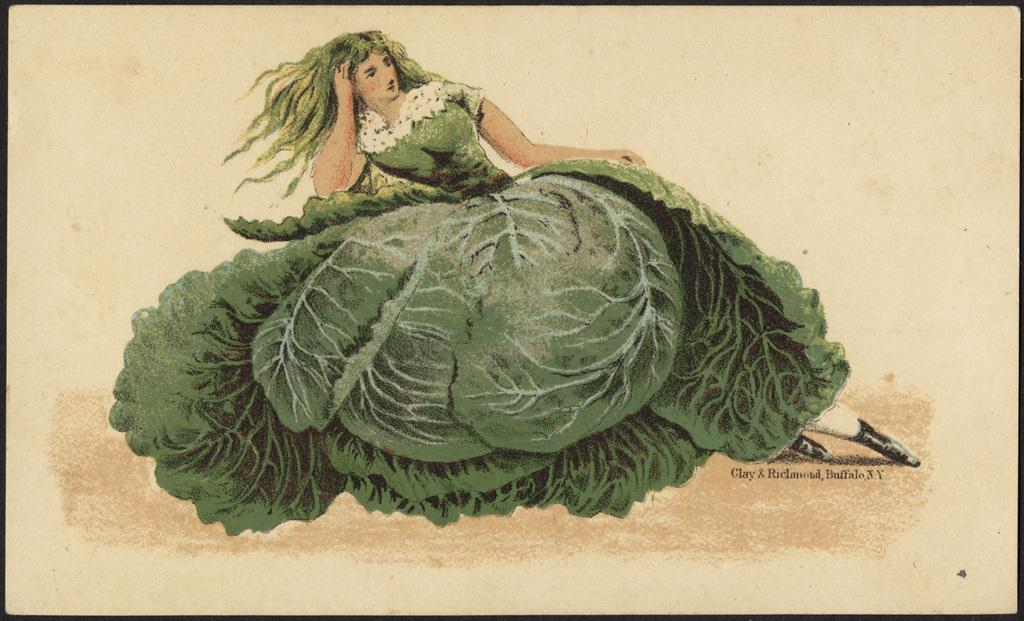What is depicted on the paper in the image? There is a drawing of a woman on the paper. What else can be seen on the paper besides the drawing? There is writing on the paper. Where is the stamp located on the paper in the image? There is no stamp present on the paper in the image. 